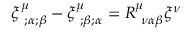Convert formula to latex. <formula><loc_0><loc_0><loc_500><loc_500>\xi _ { ; \alpha ; \beta } ^ { \mu } - \xi _ { ; \beta ; \alpha } ^ { \mu } = R _ { \nu \alpha \beta } ^ { \mu } \xi ^ { \nu }</formula> 